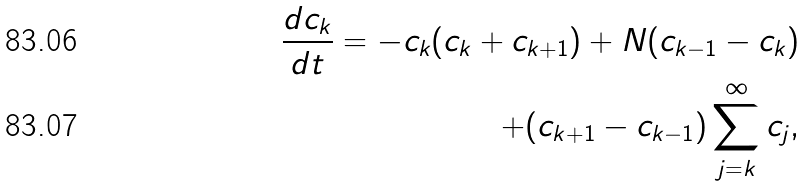<formula> <loc_0><loc_0><loc_500><loc_500>\frac { d c _ { k } } { d t } = - c _ { k } ( c _ { k } + c _ { k + 1 } ) + N ( c _ { k - 1 } - c _ { k } ) \\ + ( c _ { k + 1 } - c _ { k - 1 } ) \sum _ { j = k } ^ { \infty } c _ { j } ,</formula> 